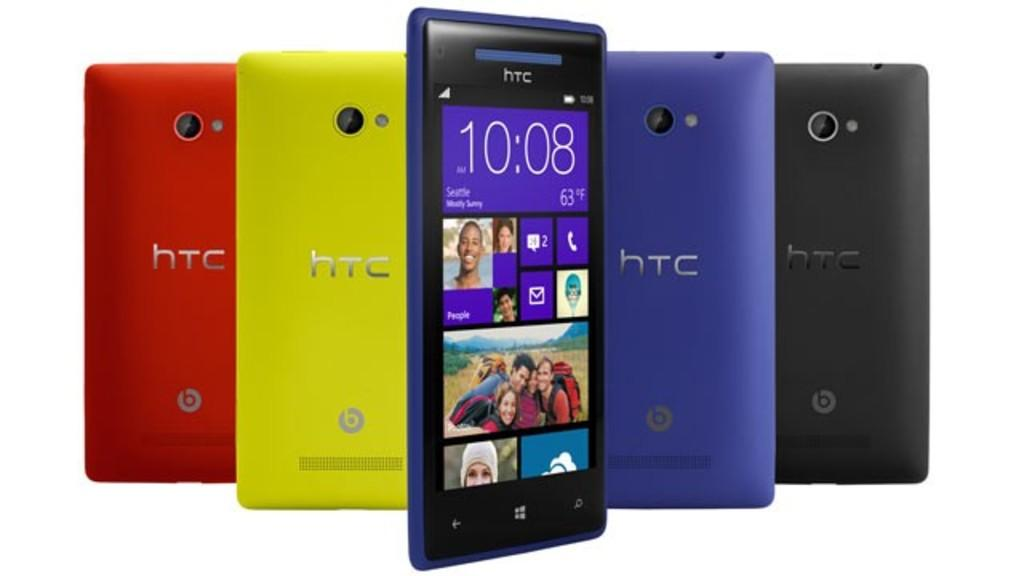<image>
Write a terse but informative summary of the picture. a display of various colors of HTC cell phones 